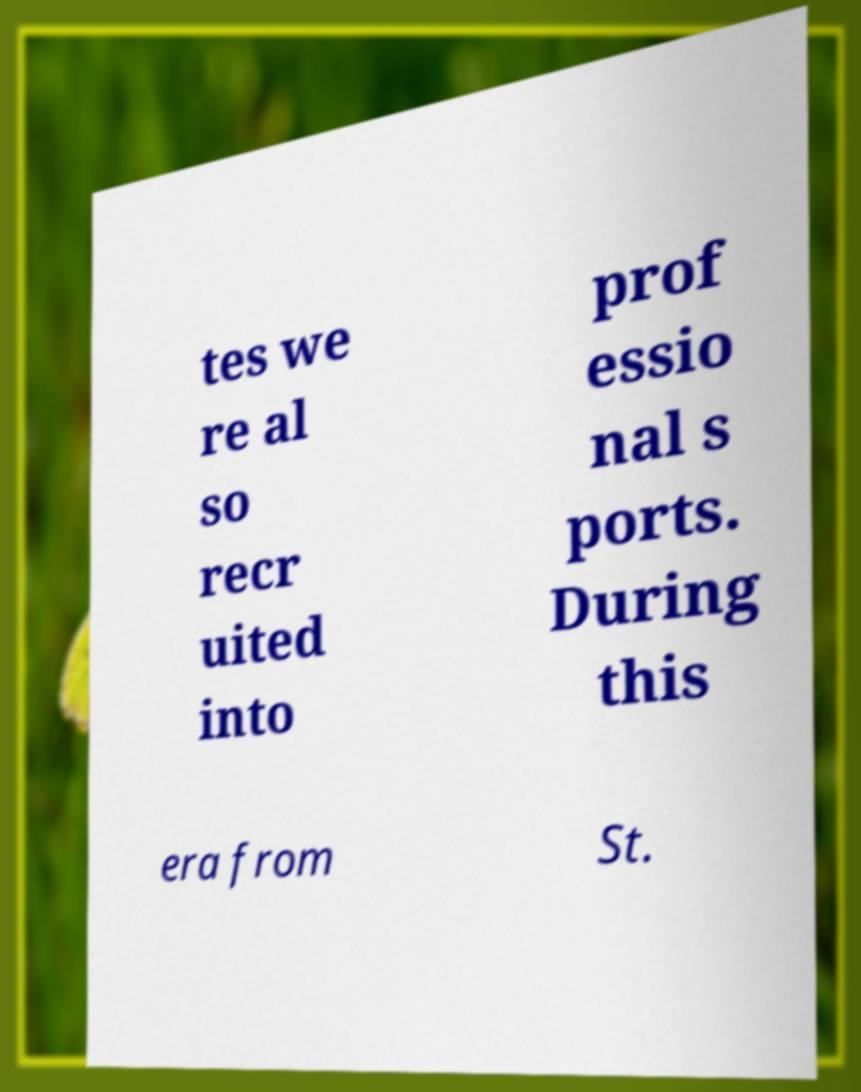Can you read and provide the text displayed in the image?This photo seems to have some interesting text. Can you extract and type it out for me? tes we re al so recr uited into prof essio nal s ports. During this era from St. 